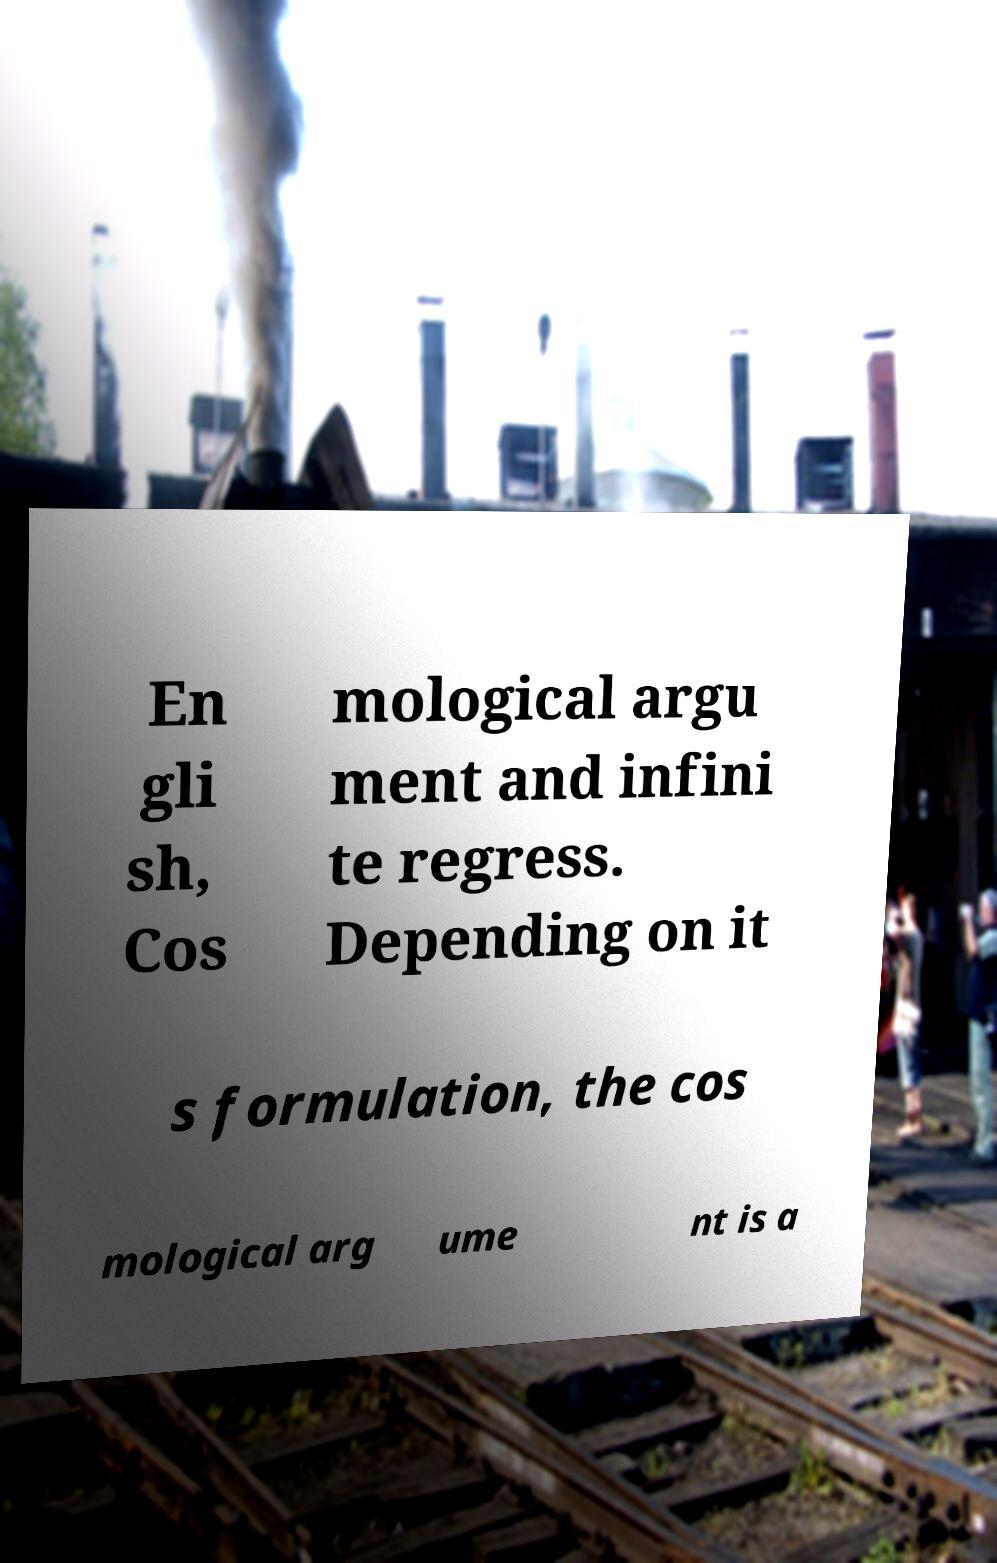I need the written content from this picture converted into text. Can you do that? En gli sh, Cos mological argu ment and infini te regress. Depending on it s formulation, the cos mological arg ume nt is a 